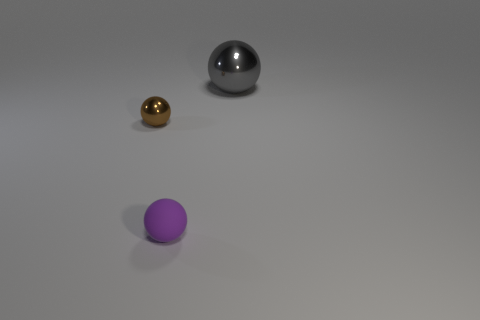Add 2 small yellow things. How many objects exist? 5 Add 3 yellow things. How many yellow things exist? 3 Subtract 0 brown blocks. How many objects are left? 3 Subtract all big green cylinders. Subtract all big gray things. How many objects are left? 2 Add 3 big balls. How many big balls are left? 4 